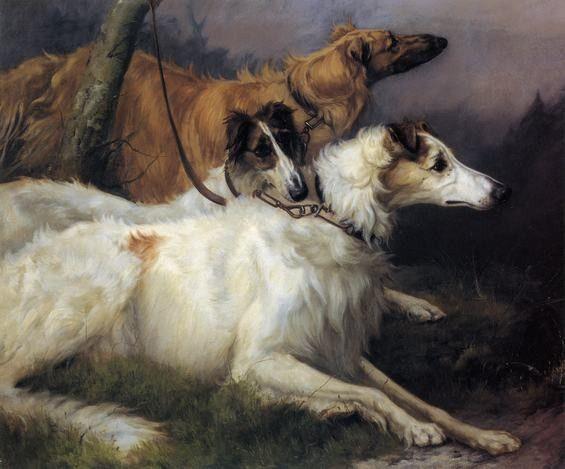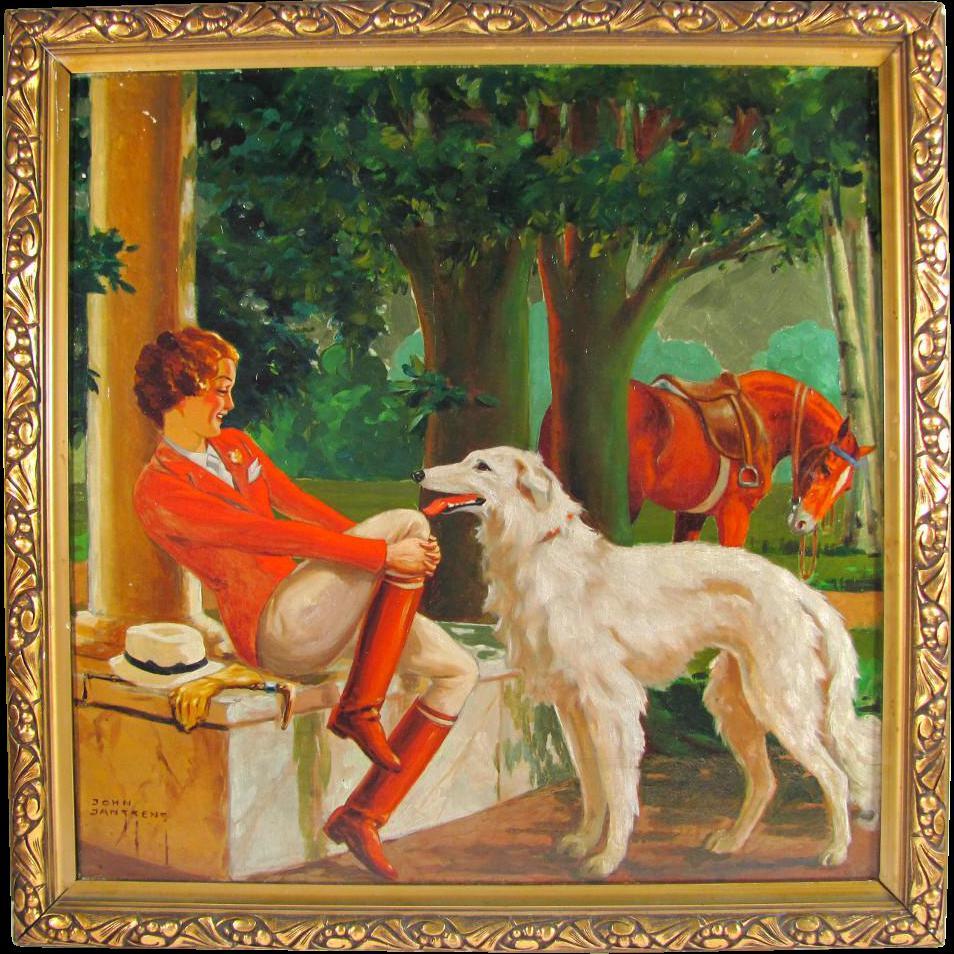The first image is the image on the left, the second image is the image on the right. Considering the images on both sides, is "There is an image with a horse" valid? Answer yes or no. Yes. 